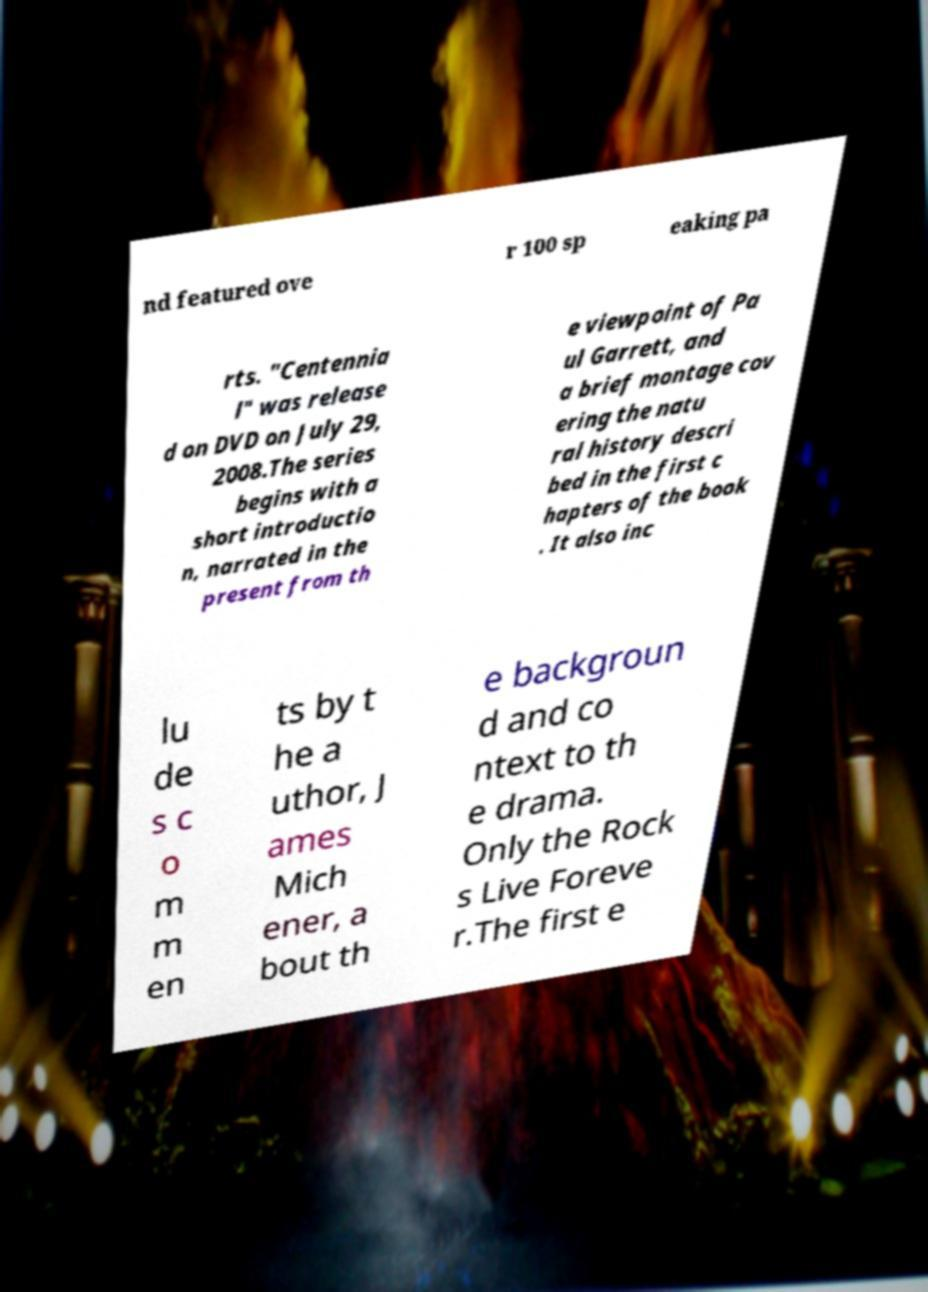Could you extract and type out the text from this image? nd featured ove r 100 sp eaking pa rts. "Centennia l" was release d on DVD on July 29, 2008.The series begins with a short introductio n, narrated in the present from th e viewpoint of Pa ul Garrett, and a brief montage cov ering the natu ral history descri bed in the first c hapters of the book . It also inc lu de s c o m m en ts by t he a uthor, J ames Mich ener, a bout th e backgroun d and co ntext to th e drama. Only the Rock s Live Foreve r.The first e 